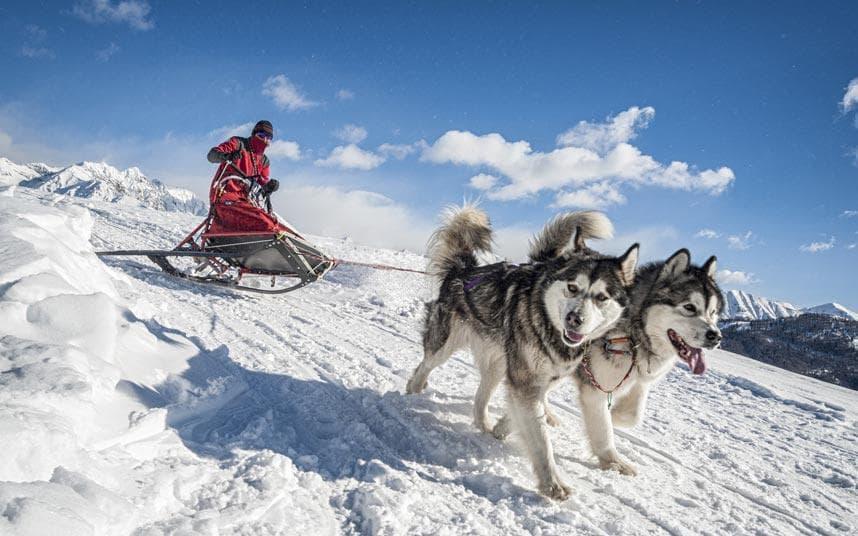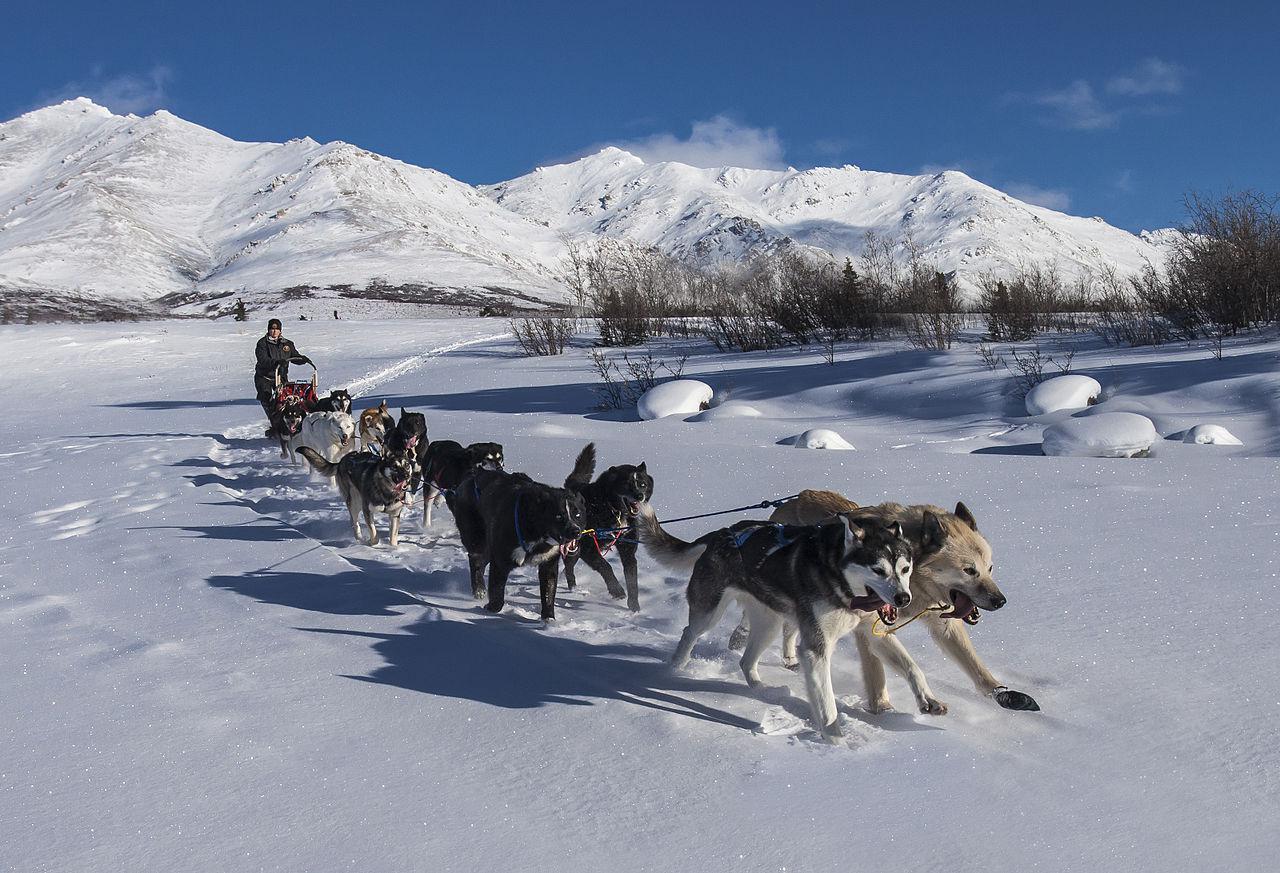The first image is the image on the left, the second image is the image on the right. For the images shown, is this caption "There is at least one human pictured." true? Answer yes or no. Yes. 